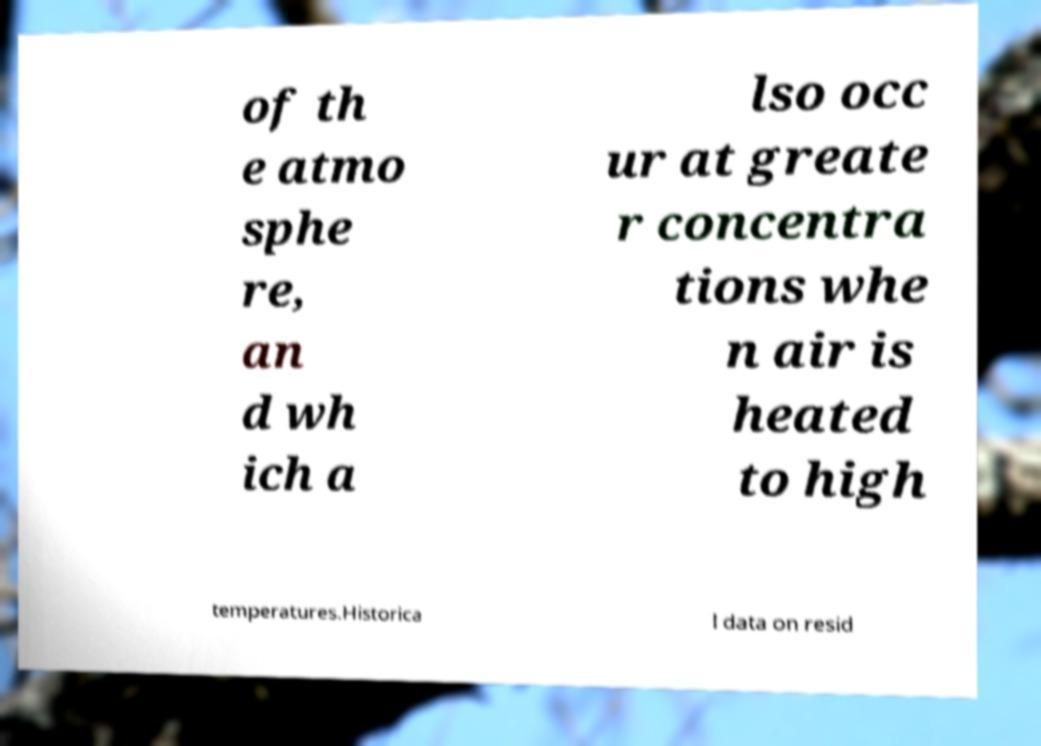What messages or text are displayed in this image? I need them in a readable, typed format. of th e atmo sphe re, an d wh ich a lso occ ur at greate r concentra tions whe n air is heated to high temperatures.Historica l data on resid 